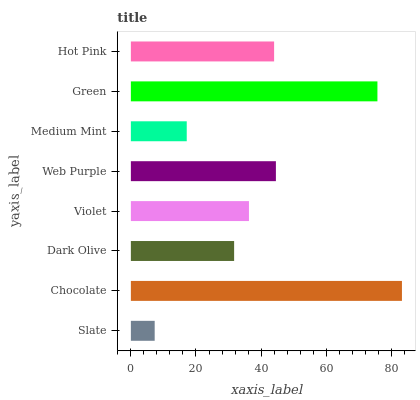Is Slate the minimum?
Answer yes or no. Yes. Is Chocolate the maximum?
Answer yes or no. Yes. Is Dark Olive the minimum?
Answer yes or no. No. Is Dark Olive the maximum?
Answer yes or no. No. Is Chocolate greater than Dark Olive?
Answer yes or no. Yes. Is Dark Olive less than Chocolate?
Answer yes or no. Yes. Is Dark Olive greater than Chocolate?
Answer yes or no. No. Is Chocolate less than Dark Olive?
Answer yes or no. No. Is Hot Pink the high median?
Answer yes or no. Yes. Is Violet the low median?
Answer yes or no. Yes. Is Violet the high median?
Answer yes or no. No. Is Chocolate the low median?
Answer yes or no. No. 